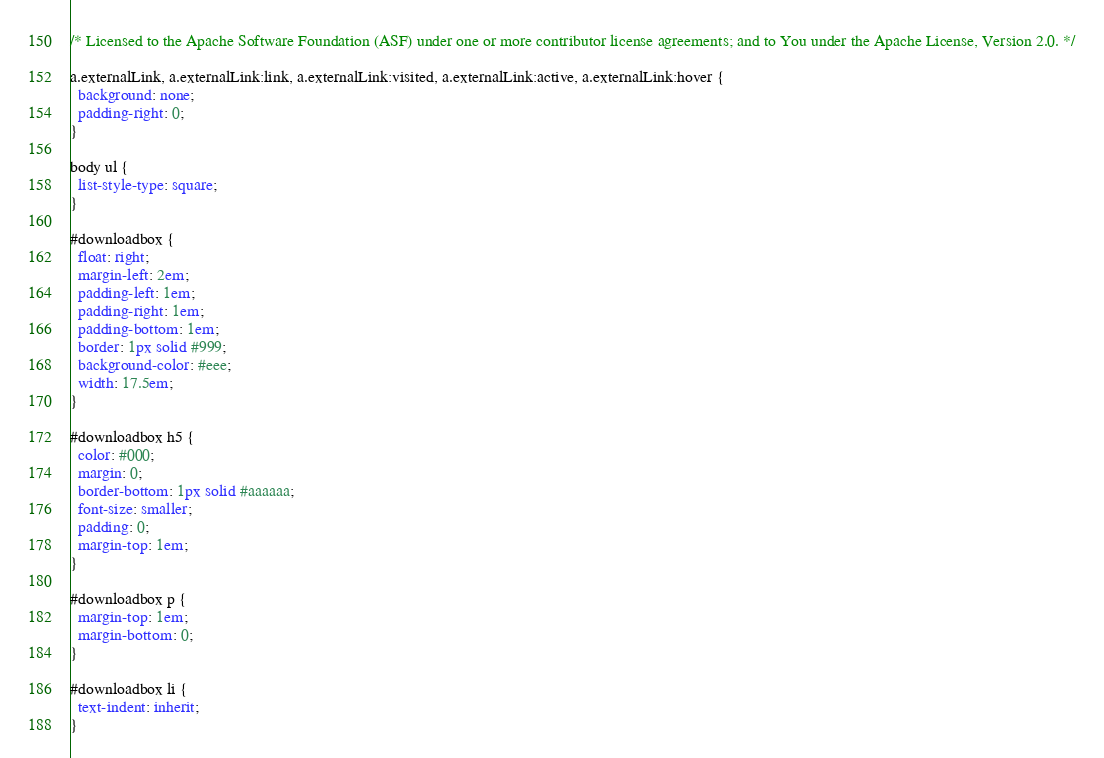Convert code to text. <code><loc_0><loc_0><loc_500><loc_500><_CSS_>/* Licensed to the Apache Software Foundation (ASF) under one or more contributor license agreements; and to You under the Apache License, Version 2.0. */

a.externalLink, a.externalLink:link, a.externalLink:visited, a.externalLink:active, a.externalLink:hover {
  background: none;
  padding-right: 0;
}

body ul {
  list-style-type: square;
}

#downloadbox {
  float: right;
  margin-left: 2em;
  padding-left: 1em;
  padding-right: 1em;
  padding-bottom: 1em;
  border: 1px solid #999;
  background-color: #eee;
  width: 17.5em;
}

#downloadbox h5 {
  color: #000;
  margin: 0;
  border-bottom: 1px solid #aaaaaa;
  font-size: smaller;
  padding: 0;
  margin-top: 1em;
}

#downloadbox p {
  margin-top: 1em;
  margin-bottom: 0;
}

#downloadbox li {
  text-indent: inherit;
}

</code> 